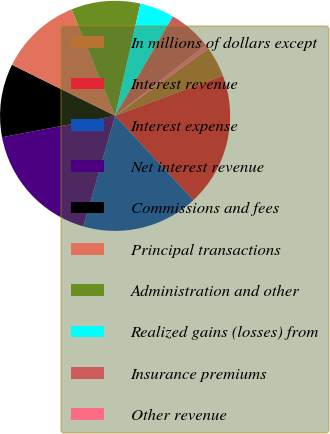Convert chart. <chart><loc_0><loc_0><loc_500><loc_500><pie_chart><fcel>In millions of dollars except<fcel>Interest revenue<fcel>Interest expense<fcel>Net interest revenue<fcel>Commissions and fees<fcel>Principal transactions<fcel>Administration and other<fcel>Realized gains (losses) from<fcel>Insurance premiums<fcel>Other revenue<nl><fcel>4.25%<fcel>18.78%<fcel>16.36%<fcel>17.57%<fcel>10.3%<fcel>11.51%<fcel>9.7%<fcel>4.85%<fcel>6.07%<fcel>0.62%<nl></chart> 